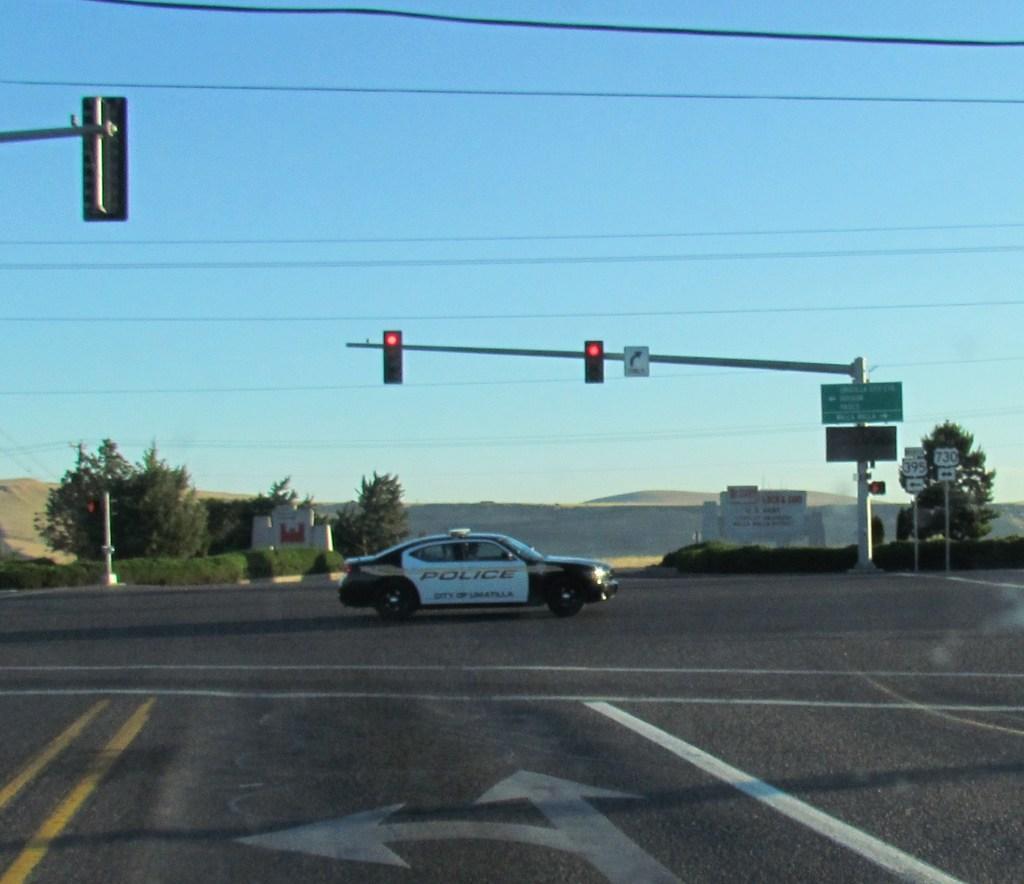Could you give a brief overview of what you see in this image? In this image there is the sky, there are wires, there is a wall, there are boards, there is text on the boards, there are poles, there is traffic lights, there are trees, there are plants, there is road, there is a car on the road, there is a pole truncated towards the left of the image, there are mountains. 